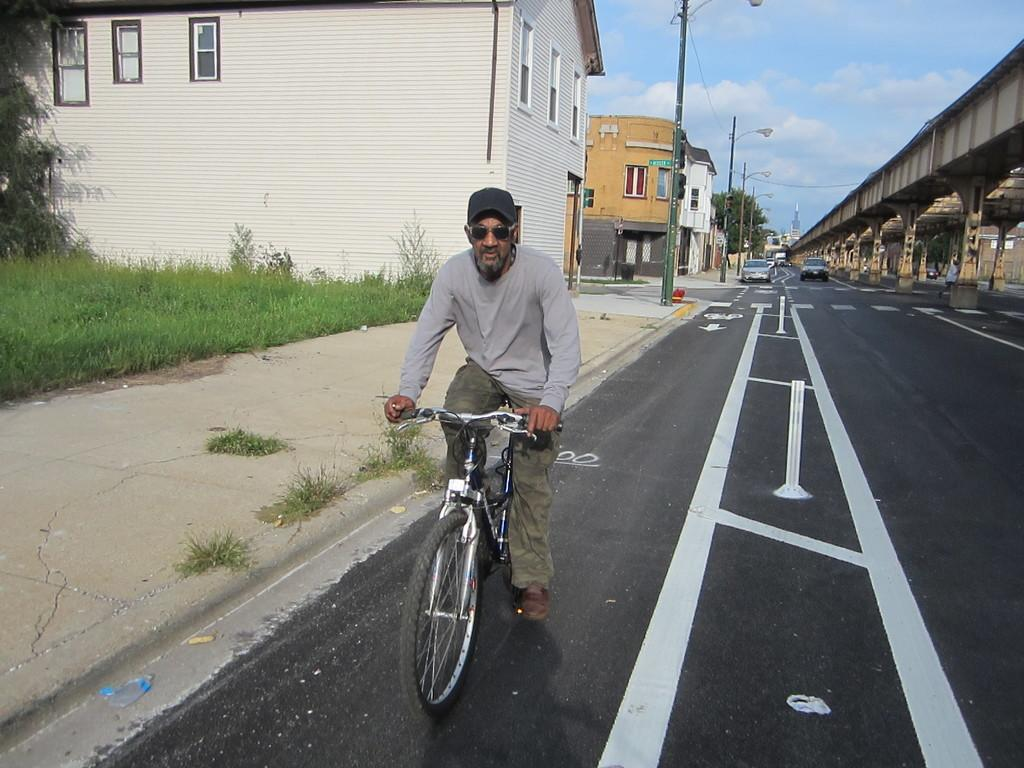What is the man in the image doing? The man is riding a bicycle in the image. What can be seen in the background of the image? There is grass, a building, a street light, a car, and a bridge in the background of the image. How many frogs are jumping on the bridge in the image? There are no frogs present in the image, and therefore no frogs can be seen jumping on the bridge. 